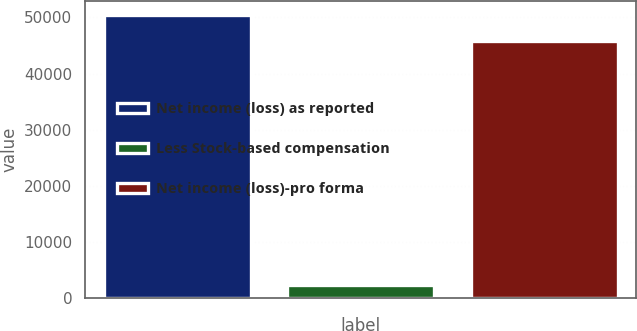<chart> <loc_0><loc_0><loc_500><loc_500><bar_chart><fcel>Net income (loss) as reported<fcel>Less Stock-based compensation<fcel>Net income (loss)-pro forma<nl><fcel>50450.4<fcel>2315<fcel>45864<nl></chart> 